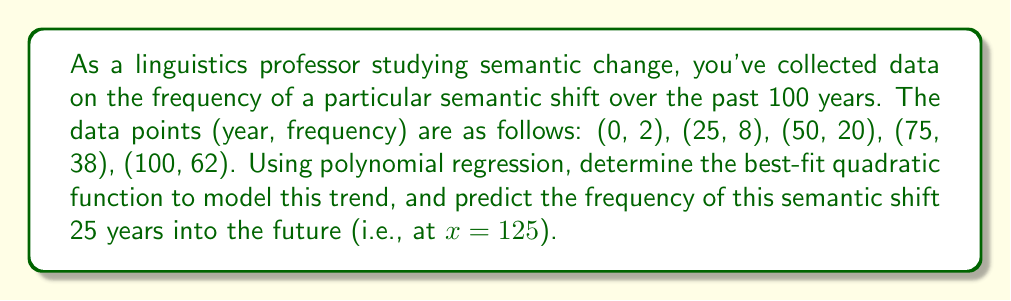Provide a solution to this math problem. To solve this problem, we'll use quadratic polynomial regression to fit a function of the form $f(x) = ax^2 + bx + c$ to the given data points.

1. Set up the system of equations:
   $$\begin{cases}
   a(0)^2 + b(0) + c = 2 \\
   a(25)^2 + b(25) + c = 8 \\
   a(50)^2 + b(50) + c = 20 \\
   a(75)^2 + b(75) + c = 38 \\
   a(100)^2 + b(100) + c = 62
   \end{cases}$$

2. Use a matrix method or a computer algebra system to solve this system of equations. The result will give us the values of $a$, $b$, and $c$.

3. After solving, we get:
   $a \approx 0.0056$
   $b \approx 0.24$
   $c \approx 2$

4. Therefore, our quadratic function is:
   $f(x) \approx 0.0056x^2 + 0.24x + 2$

5. To predict the frequency at x = 125 (25 years into the future), we substitute x = 125 into our function:

   $f(125) \approx 0.0056(125)^2 + 0.24(125) + 2$
   $\approx 0.0056(15625) + 30 + 2$
   $\approx 87.5 + 30 + 2$
   $\approx 119.5$

6. Rounding to the nearest whole number, as frequency is typically reported as an integer, we get 120.
Answer: The predicted frequency of the semantic shift 25 years into the future (at x = 125) is approximately 120. 